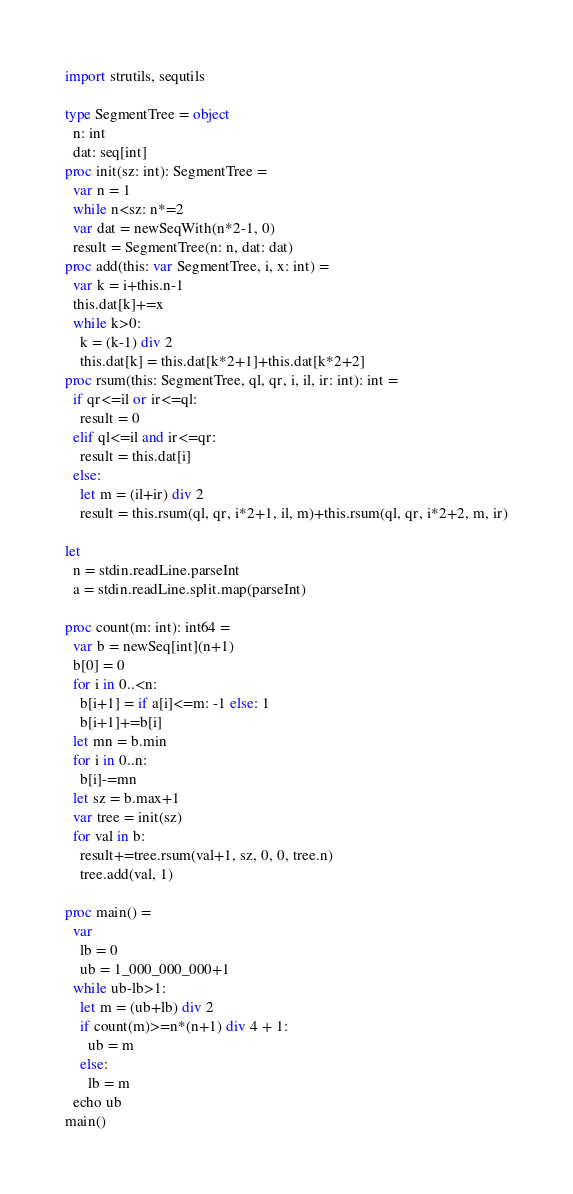Convert code to text. <code><loc_0><loc_0><loc_500><loc_500><_Nim_>import strutils, sequtils

type SegmentTree = object
  n: int
  dat: seq[int]
proc init(sz: int): SegmentTree =
  var n = 1
  while n<sz: n*=2
  var dat = newSeqWith(n*2-1, 0)
  result = SegmentTree(n: n, dat: dat)
proc add(this: var SegmentTree, i, x: int) =
  var k = i+this.n-1
  this.dat[k]+=x
  while k>0:
    k = (k-1) div 2
    this.dat[k] = this.dat[k*2+1]+this.dat[k*2+2]
proc rsum(this: SegmentTree, ql, qr, i, il, ir: int): int =
  if qr<=il or ir<=ql:
    result = 0
  elif ql<=il and ir<=qr:
    result = this.dat[i]
  else:
    let m = (il+ir) div 2
    result = this.rsum(ql, qr, i*2+1, il, m)+this.rsum(ql, qr, i*2+2, m, ir)

let
  n = stdin.readLine.parseInt
  a = stdin.readLine.split.map(parseInt)

proc count(m: int): int64 =
  var b = newSeq[int](n+1)
  b[0] = 0
  for i in 0..<n:
    b[i+1] = if a[i]<=m: -1 else: 1
    b[i+1]+=b[i]
  let mn = b.min
  for i in 0..n:
    b[i]-=mn
  let sz = b.max+1
  var tree = init(sz)
  for val in b:
    result+=tree.rsum(val+1, sz, 0, 0, tree.n)
    tree.add(val, 1)

proc main() =
  var
    lb = 0
    ub = 1_000_000_000+1
  while ub-lb>1:
    let m = (ub+lb) div 2
    if count(m)>=n*(n+1) div 4 + 1:
      ub = m
    else:
      lb = m
  echo ub
main()
</code> 